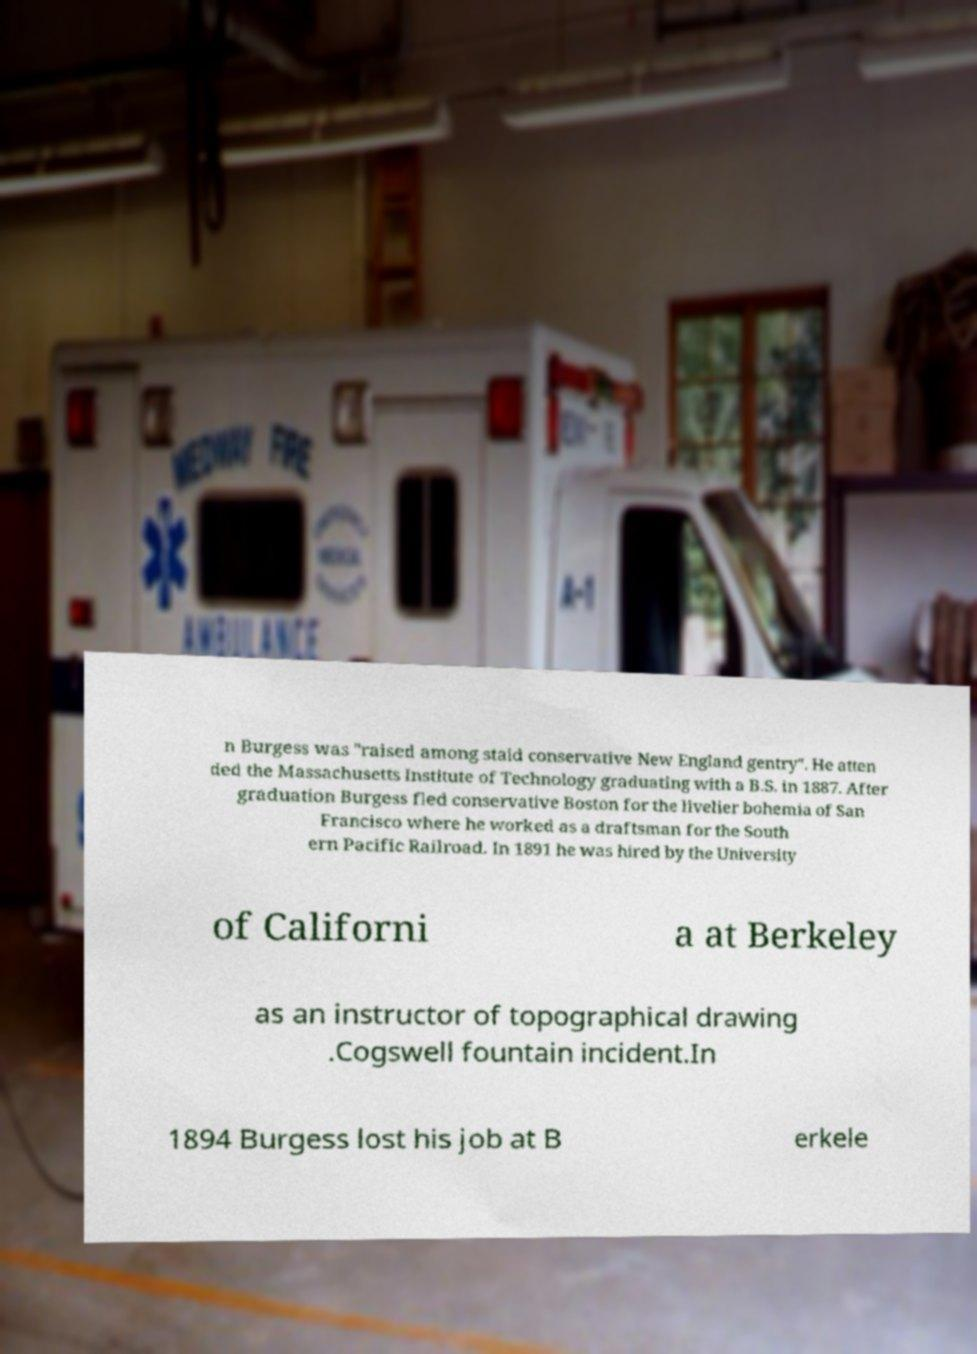I need the written content from this picture converted into text. Can you do that? n Burgess was "raised among staid conservative New England gentry". He atten ded the Massachusetts Institute of Technology graduating with a B.S. in 1887. After graduation Burgess fled conservative Boston for the livelier bohemia of San Francisco where he worked as a draftsman for the South ern Pacific Railroad. In 1891 he was hired by the University of Californi a at Berkeley as an instructor of topographical drawing .Cogswell fountain incident.In 1894 Burgess lost his job at B erkele 